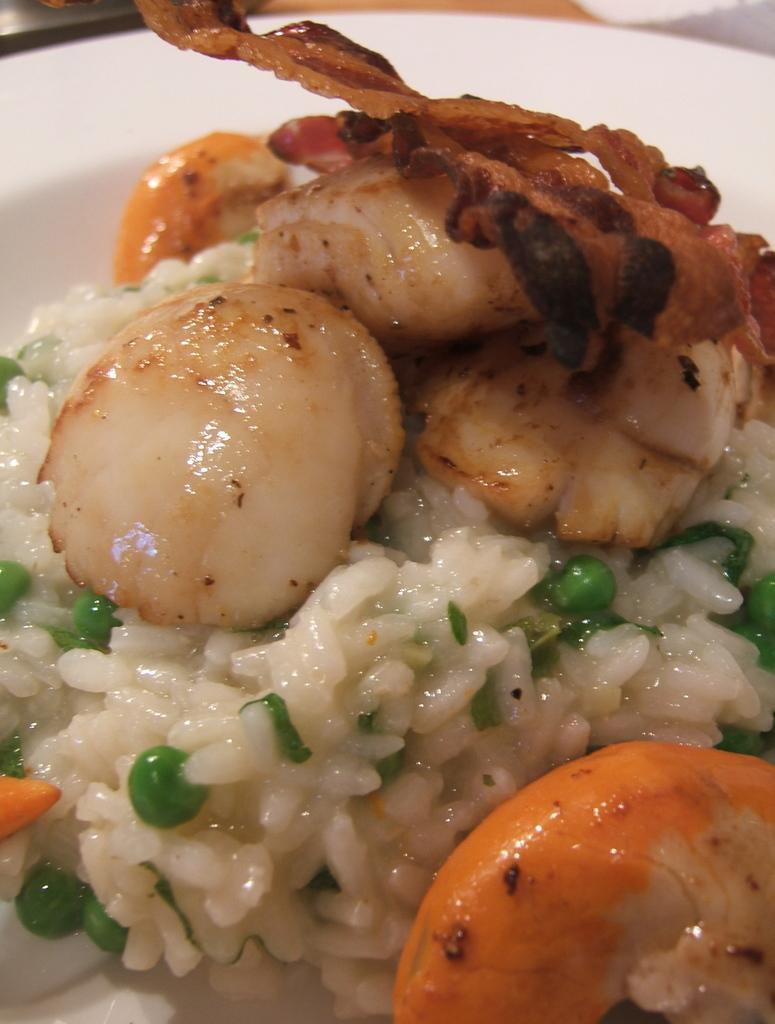Please provide a concise description of this image. In the picture I can see some food item is placed on the white color plate. 